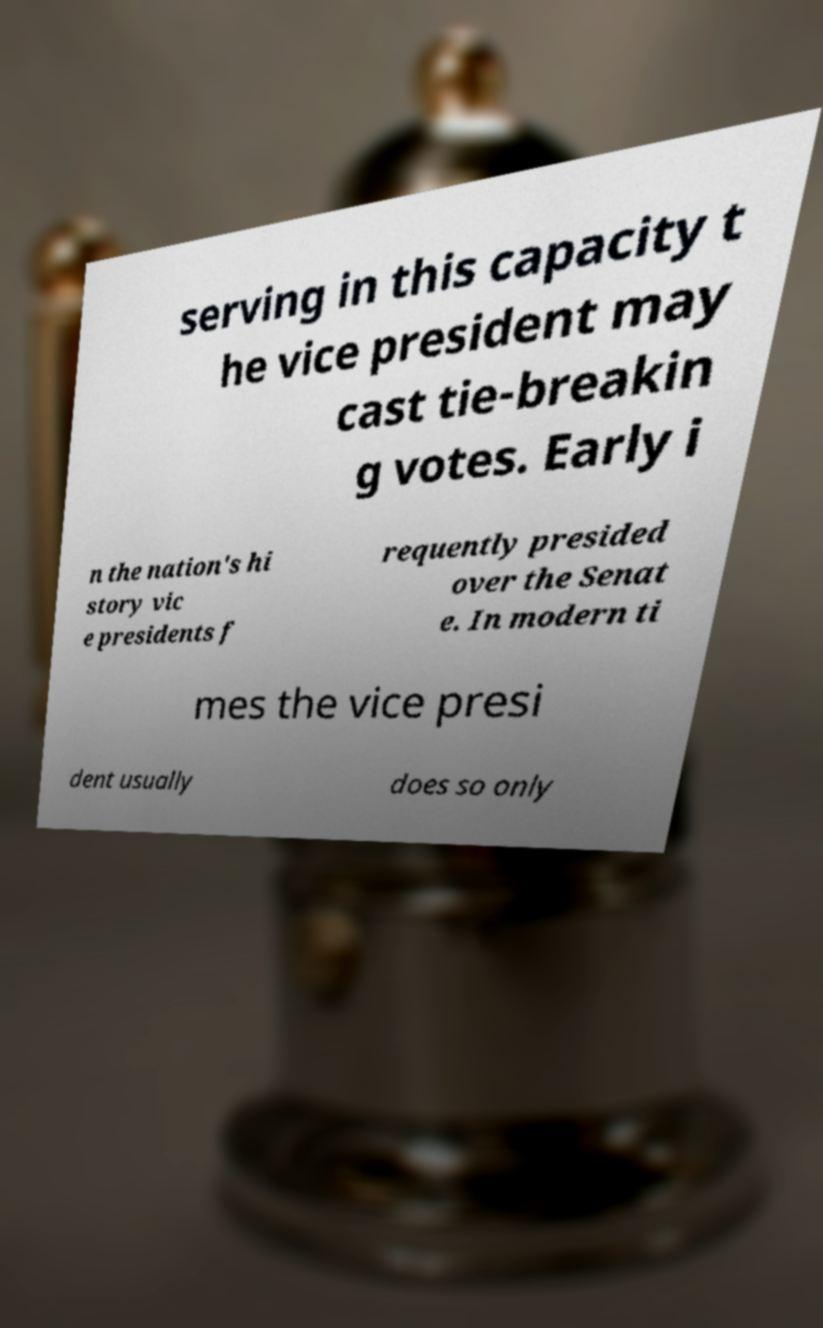There's text embedded in this image that I need extracted. Can you transcribe it verbatim? serving in this capacity t he vice president may cast tie-breakin g votes. Early i n the nation's hi story vic e presidents f requently presided over the Senat e. In modern ti mes the vice presi dent usually does so only 